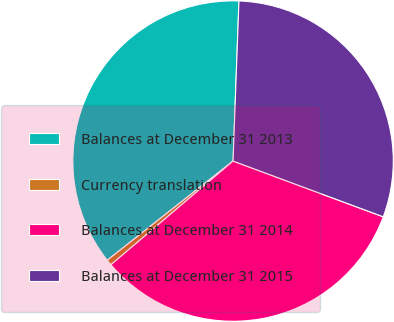Convert chart. <chart><loc_0><loc_0><loc_500><loc_500><pie_chart><fcel>Balances at December 31 2013<fcel>Currency translation<fcel>Balances at December 31 2014<fcel>Balances at December 31 2015<nl><fcel>36.21%<fcel>0.58%<fcel>33.14%<fcel>30.07%<nl></chart> 